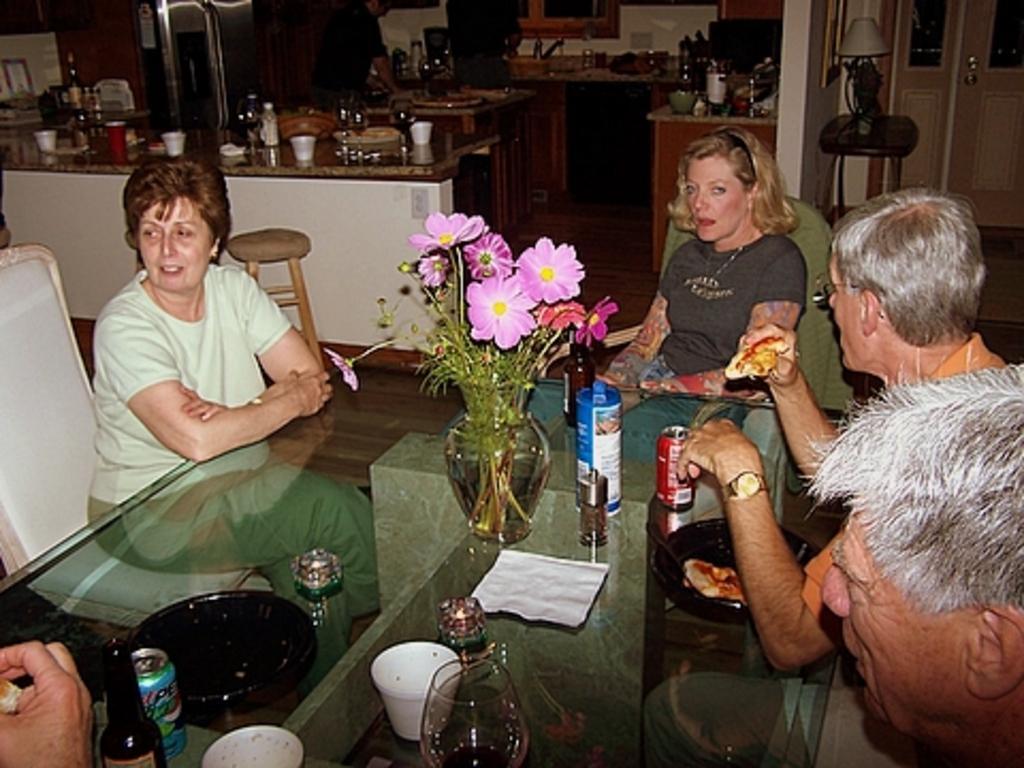Describe this image in one or two sentences. In this image we can see people sitting. At the bottom there is a table and we can see a flower vase, tins, bottles, cups and a napkin placed on the table. In the background there is a stand and we can see a lamp placed on the stand. We can see a door. There are counter tops and we can see things placed on the counter tops. There is a man and we can see a stool. 